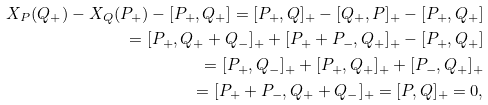<formula> <loc_0><loc_0><loc_500><loc_500>X _ { P } ( Q _ { + } ) - X _ { Q } ( P _ { + } ) - [ P _ { + } , Q _ { + } ] = [ P _ { + } , Q ] _ { + } - [ Q _ { + } , P ] _ { + } - [ P _ { + } , Q _ { + } ] \\ = [ P _ { + } , Q _ { + } + Q _ { - } ] _ { + } + [ P _ { + } + P _ { - } , Q _ { + } ] _ { + } - [ P _ { + } , Q _ { + } ] \\ = [ P _ { + } , Q _ { - } ] _ { + } + [ P _ { + } , Q _ { + } ] _ { + } + [ P _ { - } , Q _ { + } ] _ { + } \\ = [ P _ { + } + P _ { - } , Q _ { + } + Q _ { - } ] _ { + } = [ P , Q ] _ { + } = 0 ,</formula> 